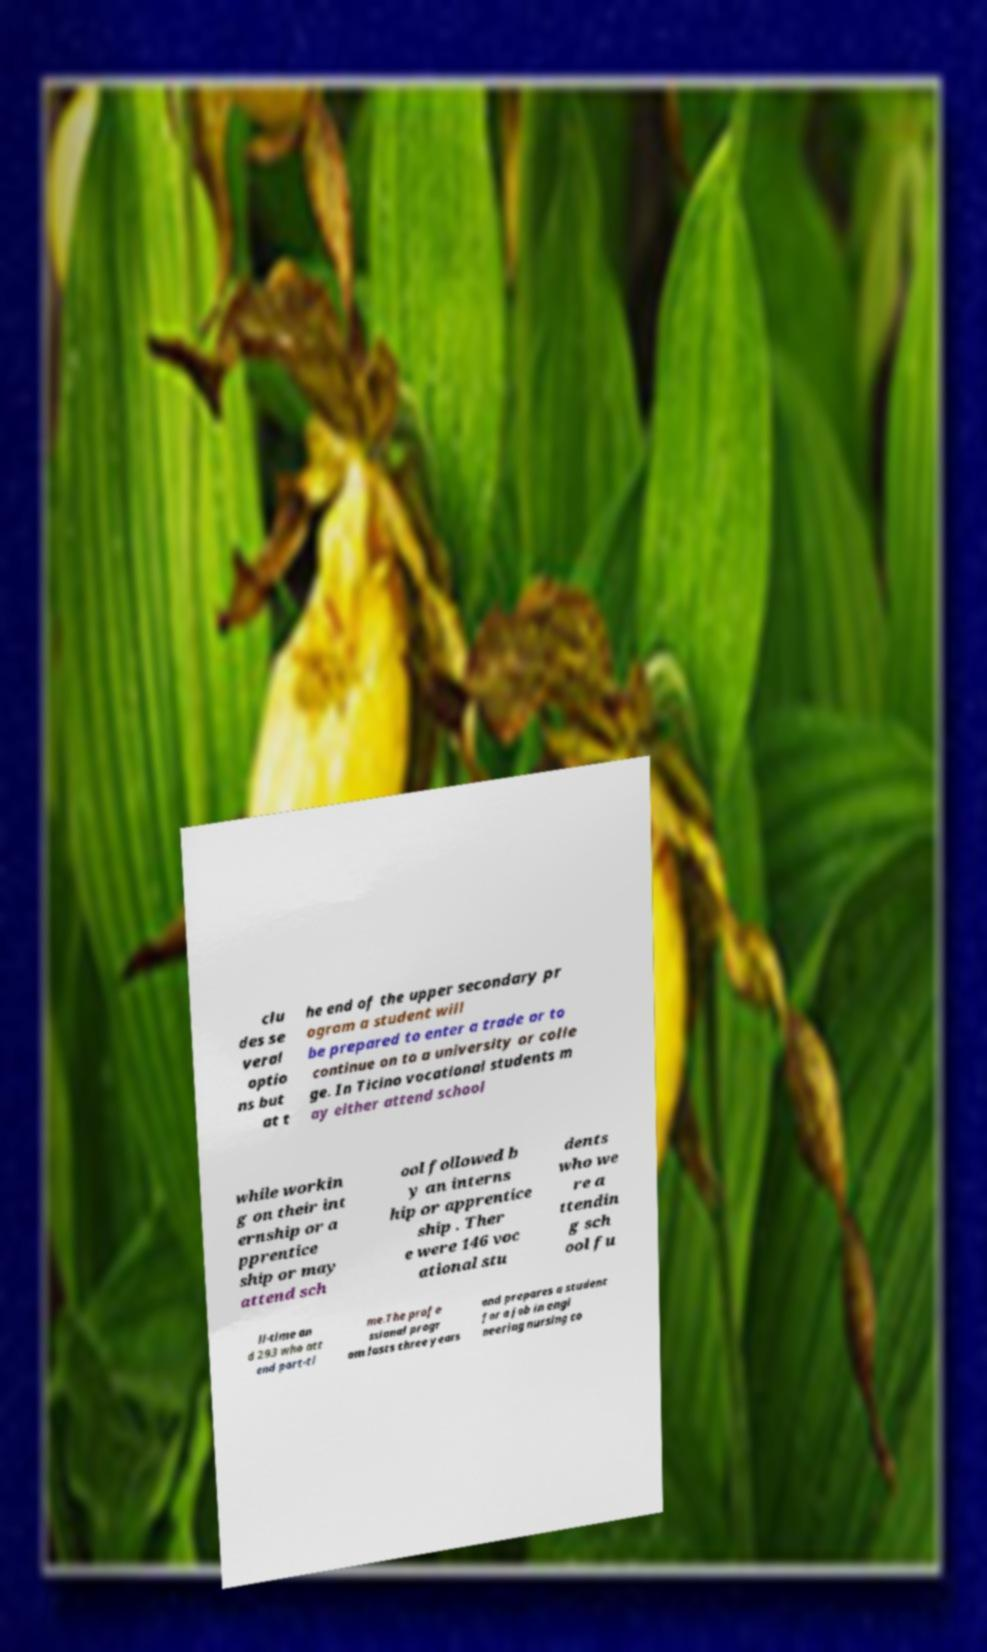Could you extract and type out the text from this image? clu des se veral optio ns but at t he end of the upper secondary pr ogram a student will be prepared to enter a trade or to continue on to a university or colle ge. In Ticino vocational students m ay either attend school while workin g on their int ernship or a pprentice ship or may attend sch ool followed b y an interns hip or apprentice ship . Ther e were 146 voc ational stu dents who we re a ttendin g sch ool fu ll-time an d 293 who att end part-ti me.The profe ssional progr am lasts three years and prepares a student for a job in engi neering nursing co 